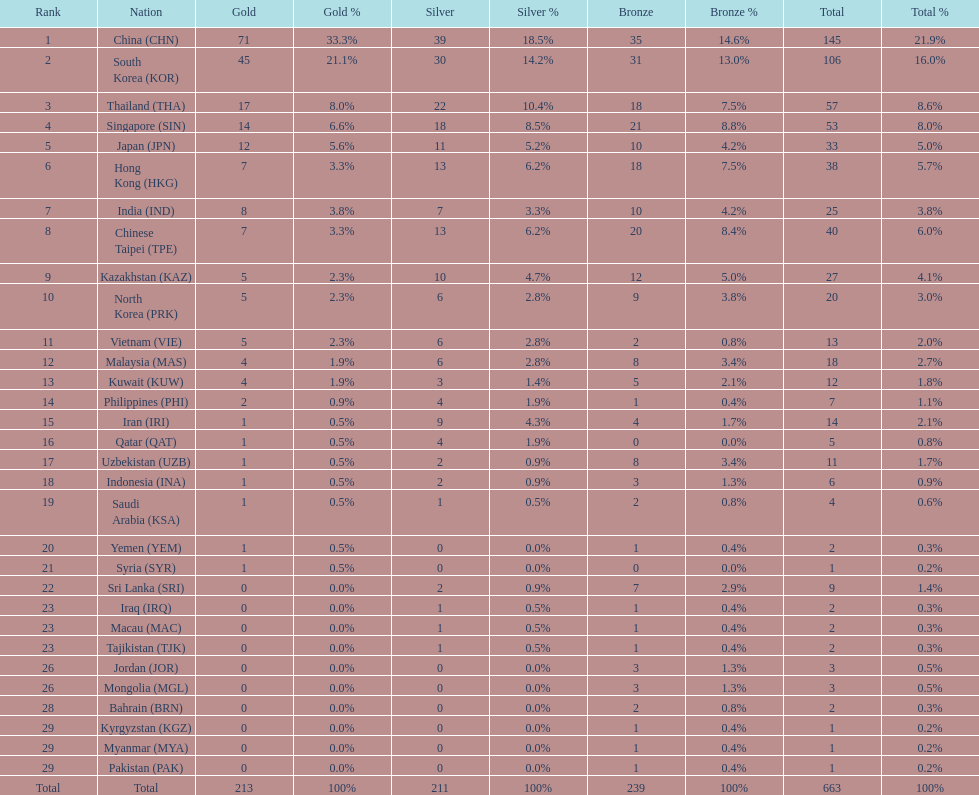What is the difference between the total amount of medals won by qatar and indonesia? 1. 